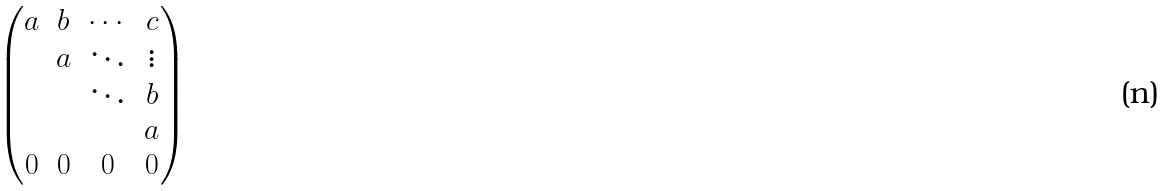<formula> <loc_0><loc_0><loc_500><loc_500>\begin{pmatrix} a & b & \cdots & c \\ & a & \ddots & \vdots \\ & & \ddots & b \\ & & & a \\ 0 & 0 & 0 & 0 \end{pmatrix}</formula> 